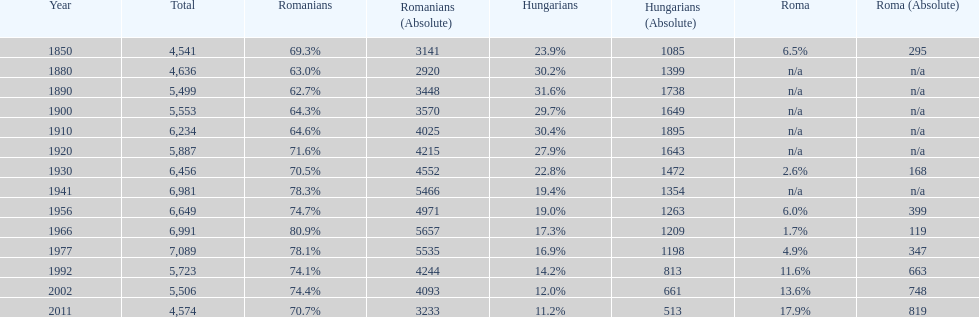What were the total number of times the romanians had a population percentage above 70%? 9. 